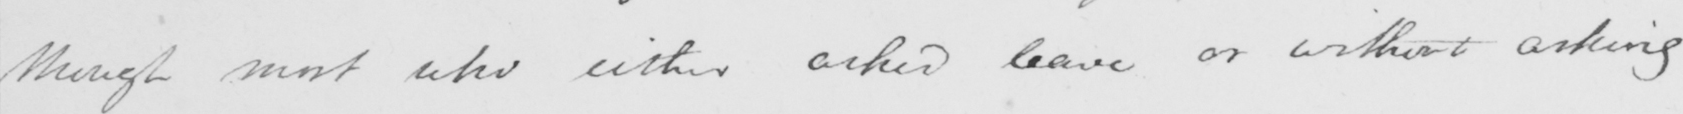Transcribe the text shown in this historical manuscript line. though most who either asked leave or without asking 